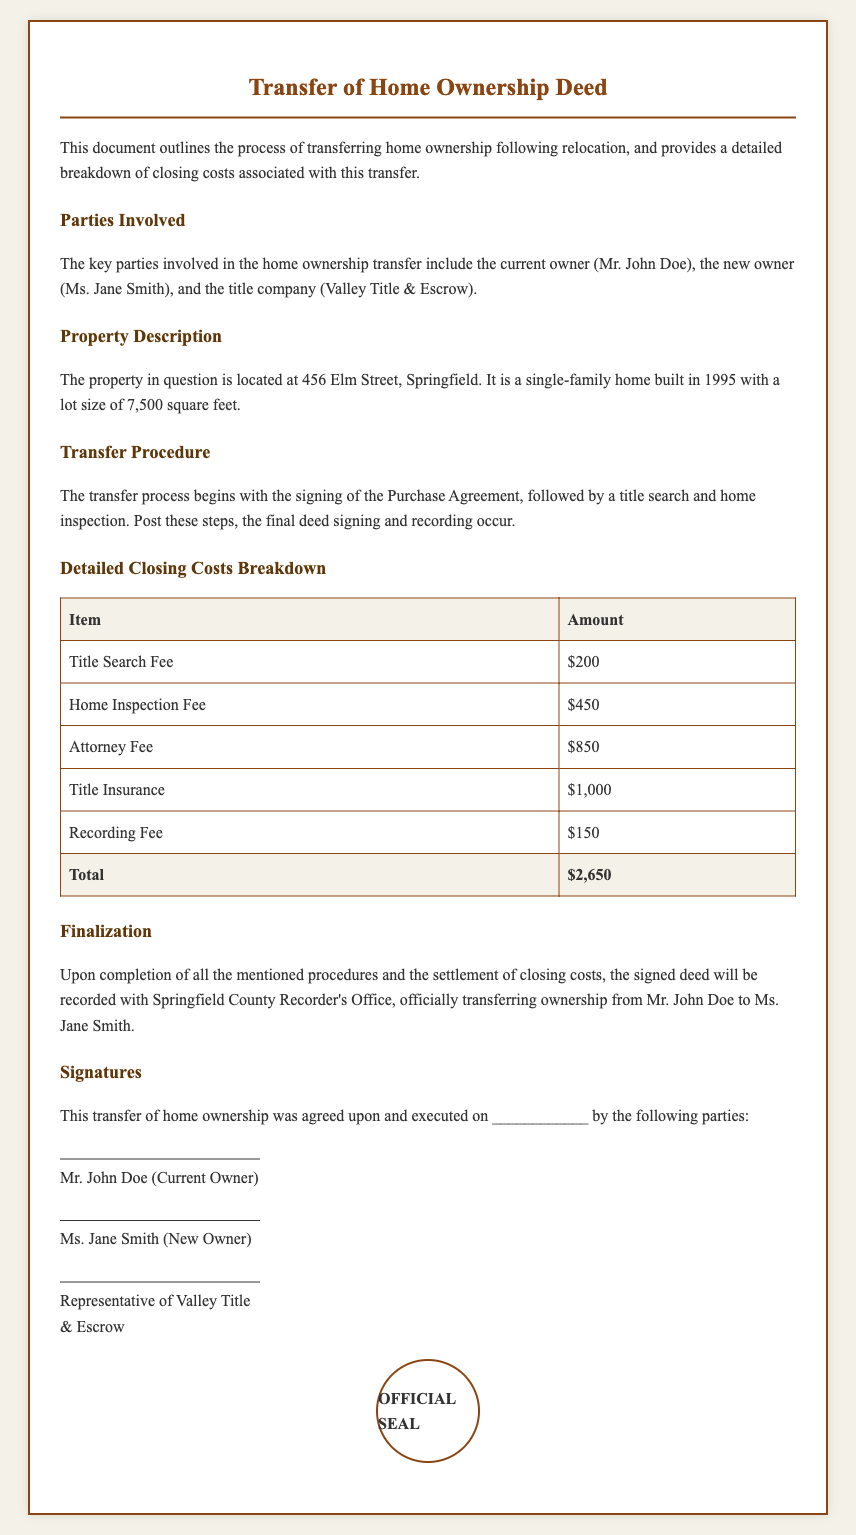What is the name of the current owner? The current owner is identified as Mr. John Doe.
Answer: Mr. John Doe What is the address of the property? The document specifies the location of the property at 456 Elm Street, Springfield.
Answer: 456 Elm Street, Springfield What is the total amount of closing costs? The total closing costs have been calculated and listed in the document as $2,650.
Answer: $2,650 What is the fee for the home inspection? The document lists the home inspection fee as one of the closing costs, which is $450.
Answer: $450 Who is the representative of the title company? The title company representative's position is mentioned but not named in the document as "Representative of Valley Title & Escrow."
Answer: Representative of Valley Title & Escrow What is one step included in the transfer procedure? The document mentions the signing of the Purchase Agreement as a step in the transfer procedure.
Answer: Signing of the Purchase Agreement How many square feet is the lot size of the property? The lot size for the property is detailed in the document as 7,500 square feet.
Answer: 7,500 square feet What signature is required for finalization? The deed must be signed by Mr. John Doe, Ms. Jane Smith, and the title company representative for finalization.
Answer: Mr. John Doe, Ms. Jane Smith, Representative of Valley Title & Escrow What date is indicated for the agreement execution? The specific date for the agreement execution is represented as a blank space labeled "________."
Answer: __________ 